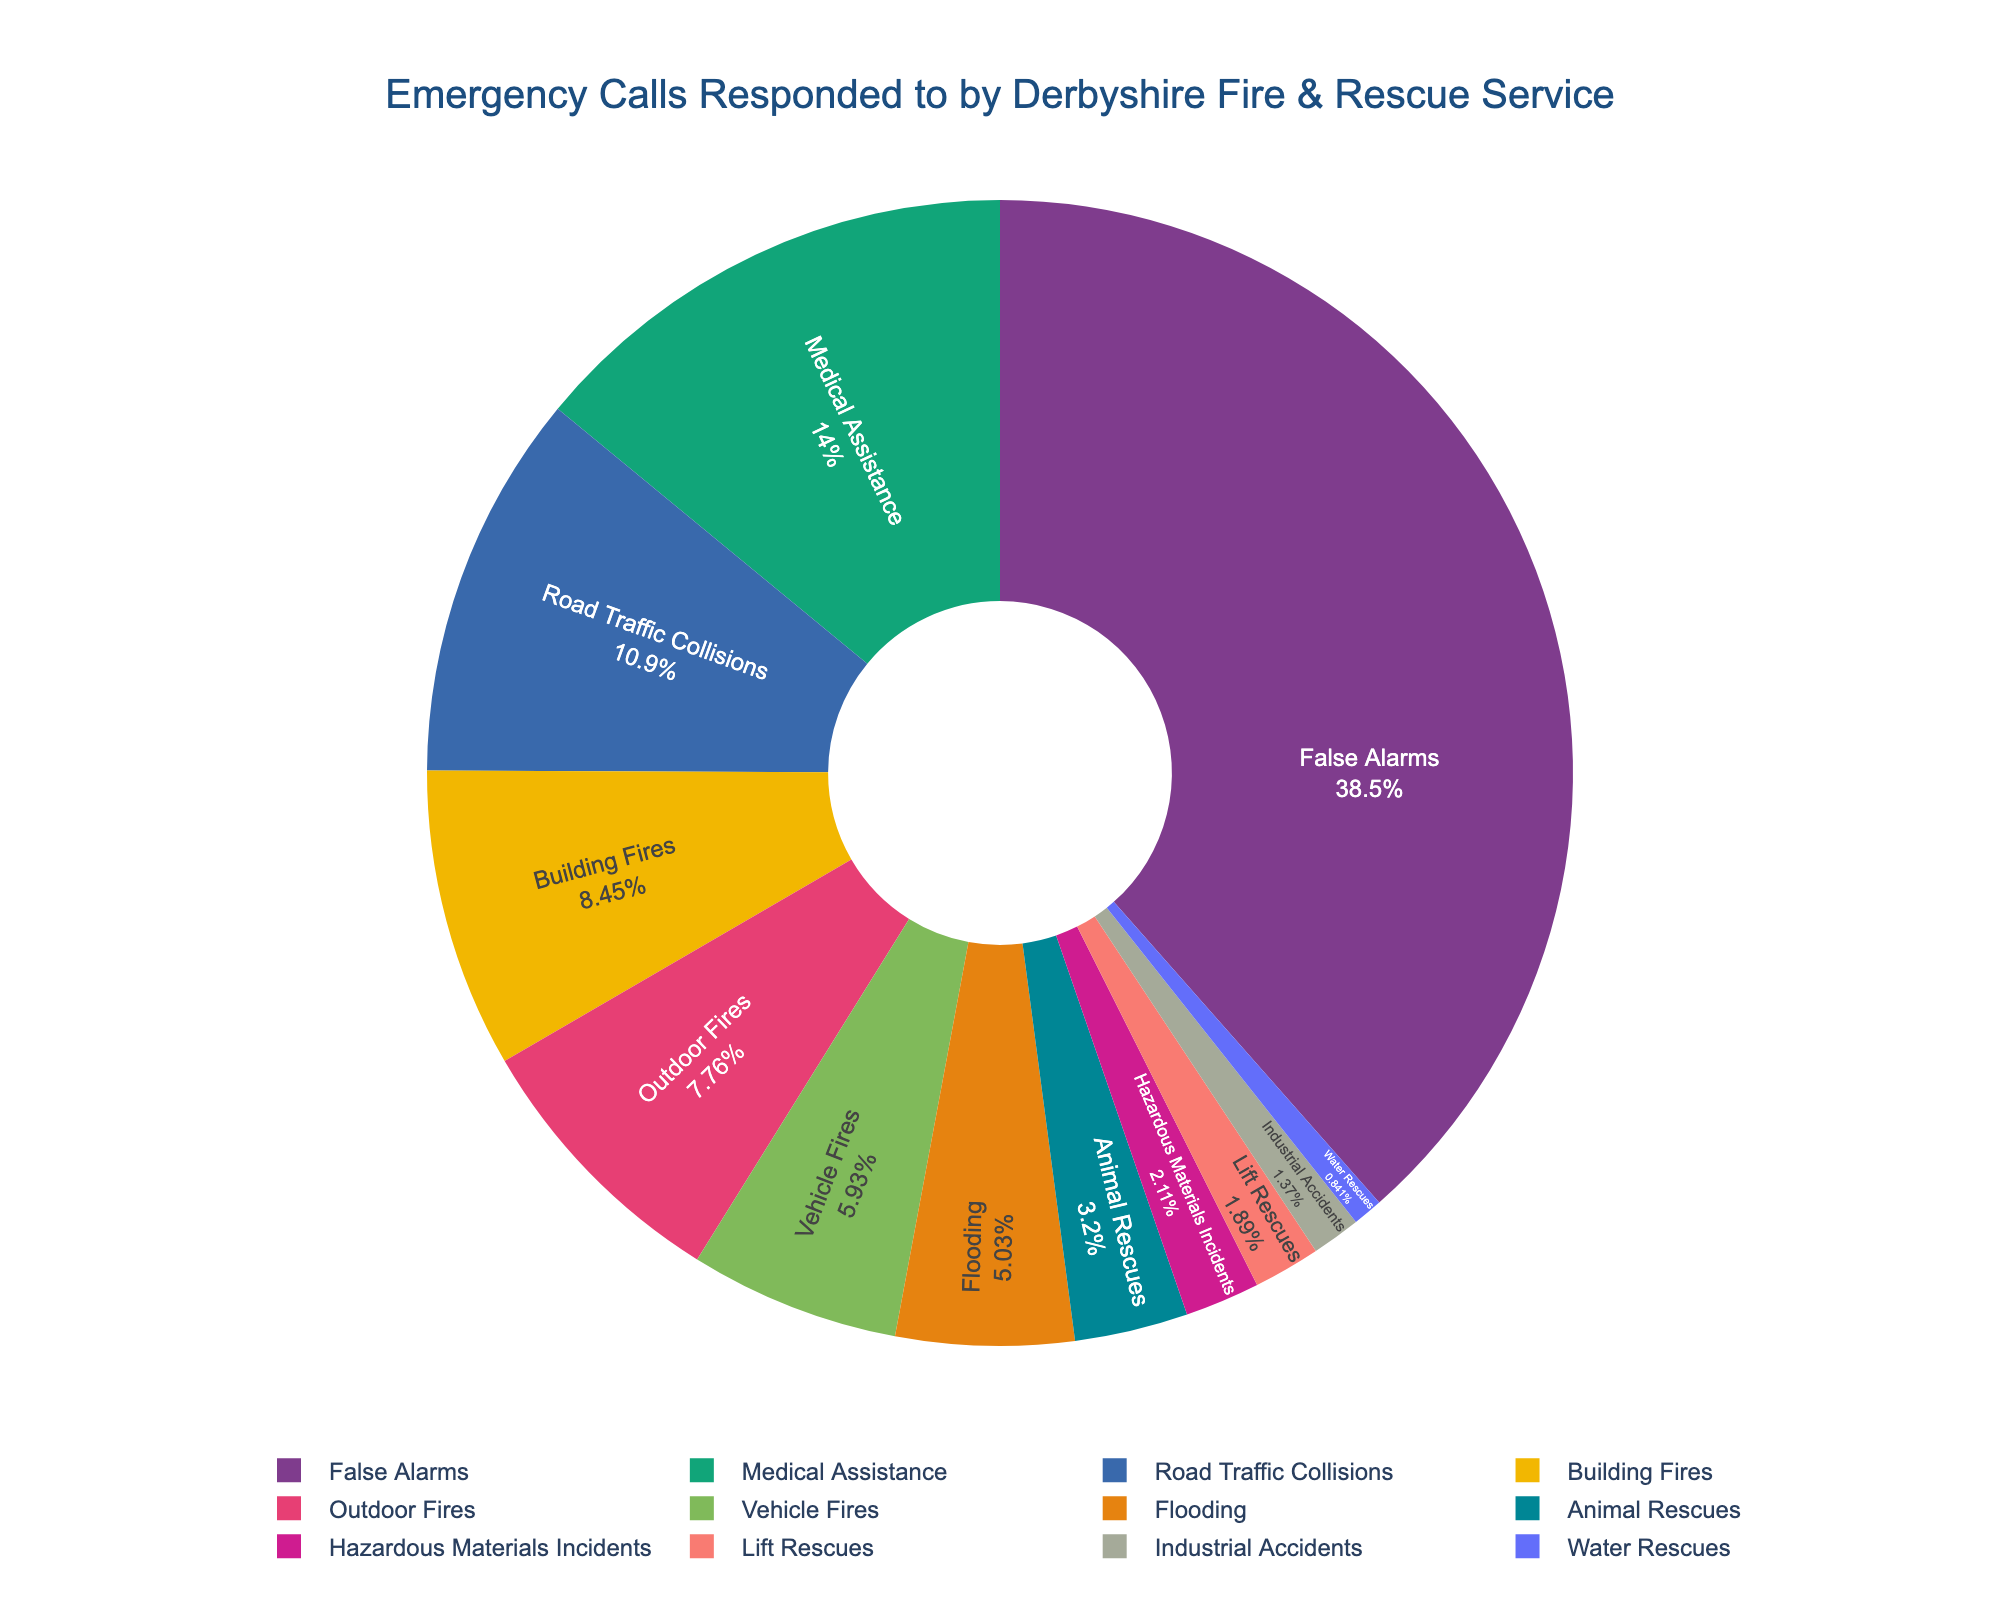Which type of emergency call was the most common? The segment with the highest percentage on the pie chart corresponds to False Alarms.
Answer: False Alarms What percentage of the emergency calls were medical assistance calls? Locate the Medical Assistance segment in the pie chart and note its labeled percentage.
Answer: 13.3% Which type of emergency call was the least frequent? Find the smallest segment in the pie chart, which represents Water Rescues.
Answer: Water Rescues How many more Road Traffic Collisions were there compared to Building Fires? Road Traffic Collisions had 531 calls and Building Fires had 412. Subtract the smaller number from the larger number (531 - 412).
Answer: 119 What two types of emergency calls have almost equal numbers? Identify the segments that are similar in size; Medical Assistance (684) and Road Traffic Collisions (531) are reasonably close, but another close pair is Building Fires (412) and Outdoor Fires (378). Calculate their differences to confirm.
Answer: Building Fires and Outdoor Fires Which type of emergency calls had fewer incidents, Flooding or Vehicle Fires? Compare the percentages for Flooding and Vehicle Fires directly on the chart.
Answer: Vehicle Fires How does the number of False Alarms compare to the rest of the emergency calls combined? Calculate the total number of calls first, then subtract the number of False Alarms from the total. Compare if False Alarms alone outnumber the sum of all other categories.
Answer: False Alarms exceed the sum of all other categories If the second-largest type (Medical Assistance) had twice as many calls, how would it compare to False Alarms? Double the number of Medical Assistance calls: 684 * 2 = 1368, which is still less than the 1876 False Alarms.
Answer: Still less than False Alarms 